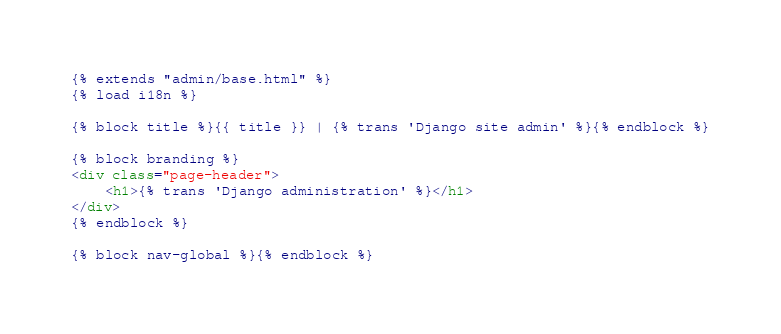<code> <loc_0><loc_0><loc_500><loc_500><_HTML_>{% extends "admin/base.html" %}
{% load i18n %}

{% block title %}{{ title }} | {% trans 'Django site admin' %}{% endblock %}

{% block branding %}
<div class="page-header">
    <h1>{% trans 'Django administration' %}</h1>
</div>
{% endblock %}

{% block nav-global %}{% endblock %} </code> 